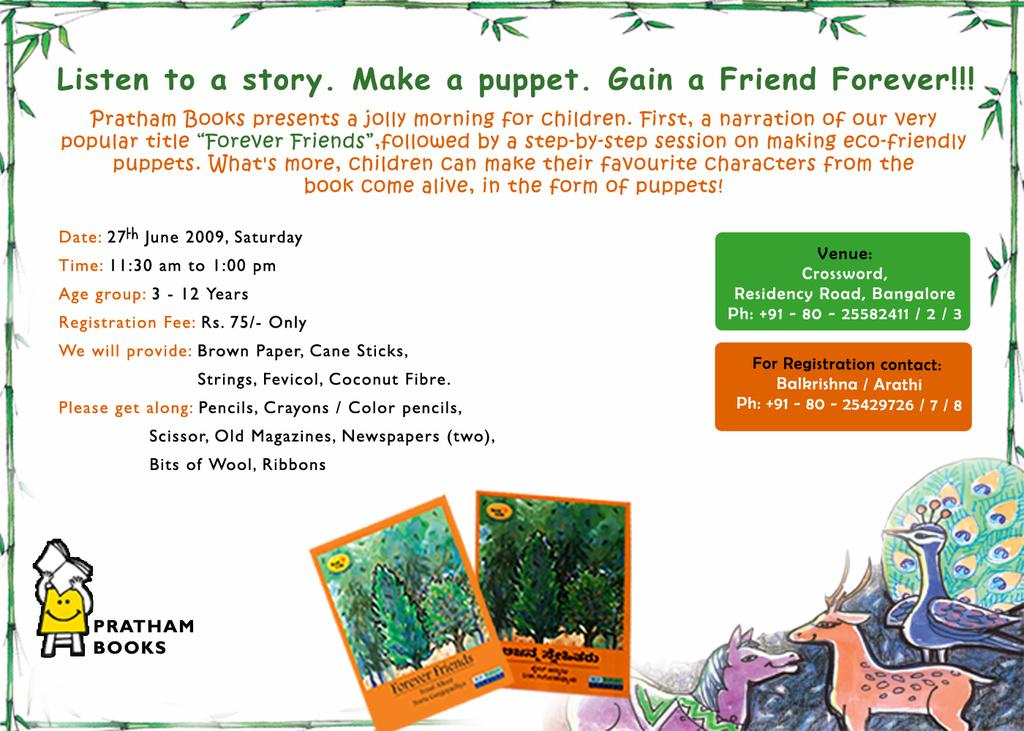What is the main subject of the image? The main subject of the image is a picture. What elements are included in the picture? The picture contains text and trees. What can be seen on the right side of the image? There are cartoons on the right side of the image. What type of rings can be seen in the image? There are no rings present in the image. What treatment is being administered to the trees in the image? There is no treatment being administered to the trees in the image; they are simply depicted in the picture. 